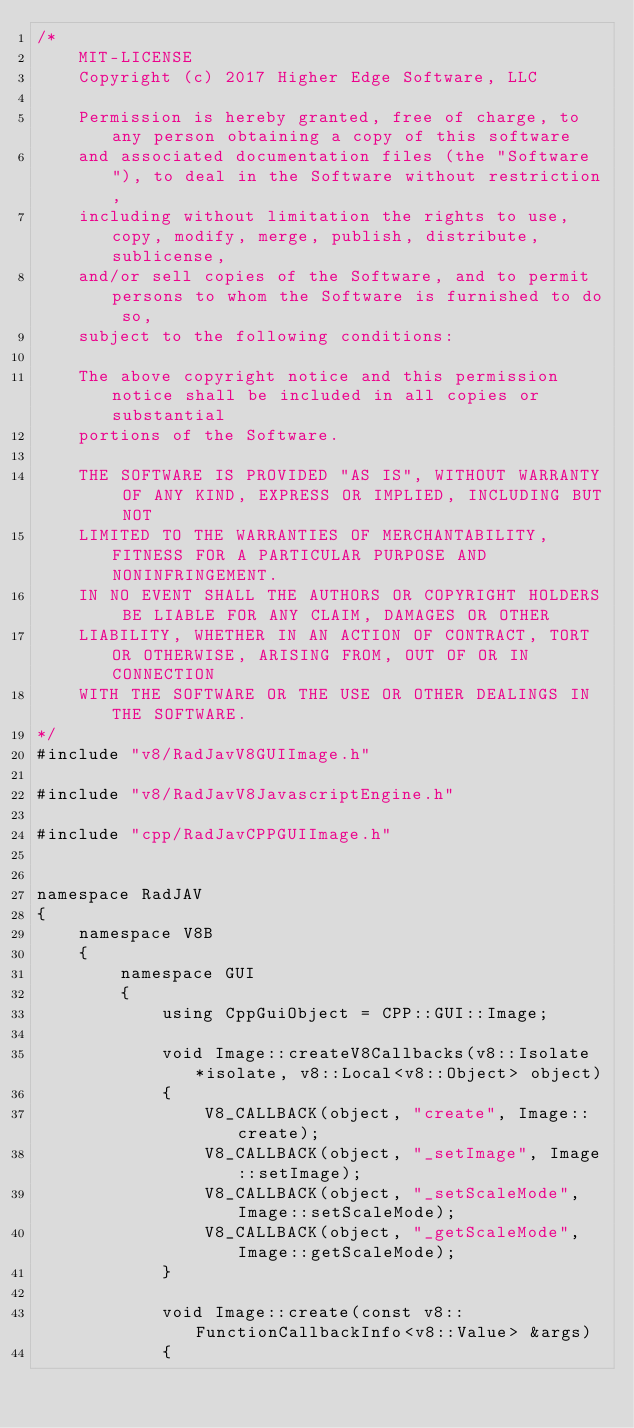Convert code to text. <code><loc_0><loc_0><loc_500><loc_500><_C++_>/*
	MIT-LICENSE
	Copyright (c) 2017 Higher Edge Software, LLC

	Permission is hereby granted, free of charge, to any person obtaining a copy of this software 
	and associated documentation files (the "Software"), to deal in the Software without restriction, 
	including without limitation the rights to use, copy, modify, merge, publish, distribute, sublicense, 
	and/or sell copies of the Software, and to permit persons to whom the Software is furnished to do so, 
	subject to the following conditions:

	The above copyright notice and this permission notice shall be included in all copies or substantial 
	portions of the Software.

	THE SOFTWARE IS PROVIDED "AS IS", WITHOUT WARRANTY OF ANY KIND, EXPRESS OR IMPLIED, INCLUDING BUT NOT 
	LIMITED TO THE WARRANTIES OF MERCHANTABILITY, FITNESS FOR A PARTICULAR PURPOSE AND NONINFRINGEMENT. 
	IN NO EVENT SHALL THE AUTHORS OR COPYRIGHT HOLDERS BE LIABLE FOR ANY CLAIM, DAMAGES OR OTHER 
	LIABILITY, WHETHER IN AN ACTION OF CONTRACT, TORT OR OTHERWISE, ARISING FROM, OUT OF OR IN CONNECTION 
	WITH THE SOFTWARE OR THE USE OR OTHER DEALINGS IN THE SOFTWARE.
*/
#include "v8/RadJavV8GUIImage.h"

#include "v8/RadJavV8JavascriptEngine.h"

#include "cpp/RadJavCPPGUIImage.h"


namespace RadJAV
{
	namespace V8B
	{
		namespace GUI
		{
			using CppGuiObject = CPP::GUI::Image;
			
			void Image::createV8Callbacks(v8::Isolate *isolate, v8::Local<v8::Object> object)
			{
				V8_CALLBACK(object, "create", Image::create);
				V8_CALLBACK(object, "_setImage", Image::setImage);
				V8_CALLBACK(object, "_setScaleMode", Image::setScaleMode);
				V8_CALLBACK(object, "_getScaleMode", Image::getScaleMode);
			}

			void Image::create(const v8::FunctionCallbackInfo<v8::Value> &args)
			{</code> 